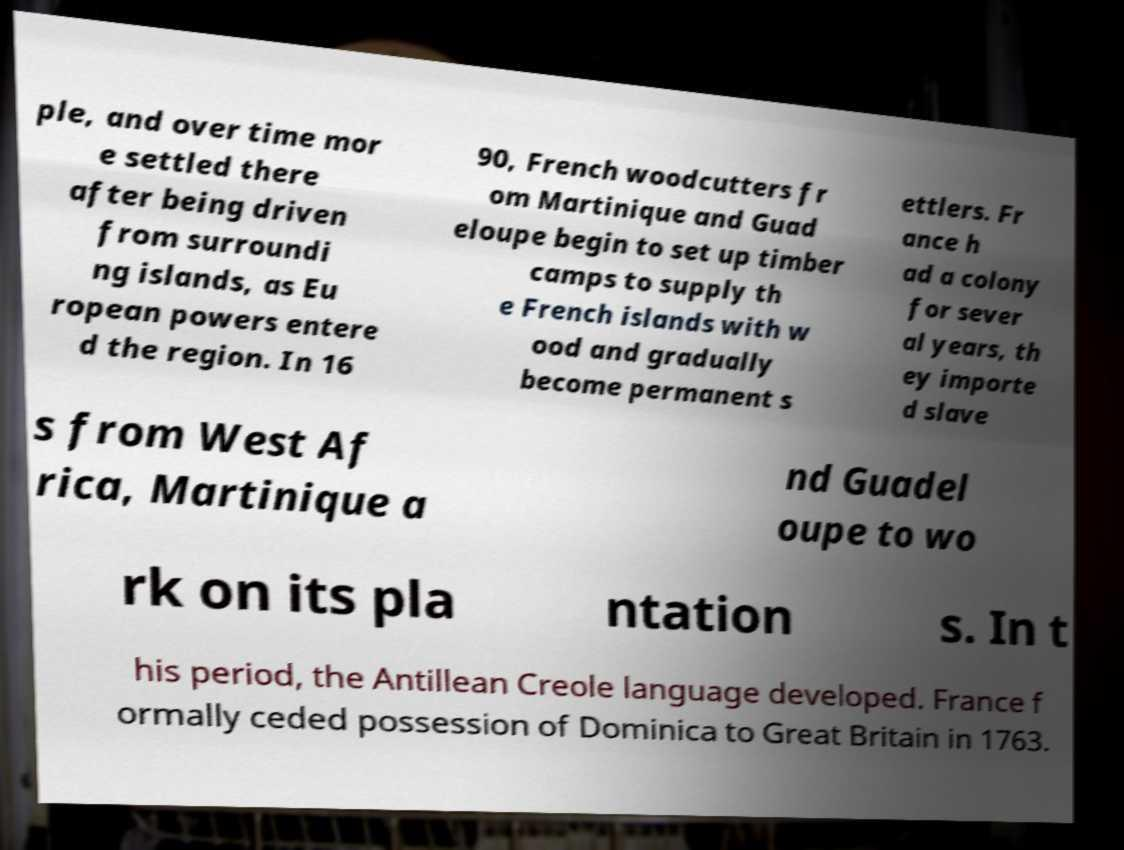For documentation purposes, I need the text within this image transcribed. Could you provide that? ple, and over time mor e settled there after being driven from surroundi ng islands, as Eu ropean powers entere d the region. In 16 90, French woodcutters fr om Martinique and Guad eloupe begin to set up timber camps to supply th e French islands with w ood and gradually become permanent s ettlers. Fr ance h ad a colony for sever al years, th ey importe d slave s from West Af rica, Martinique a nd Guadel oupe to wo rk on its pla ntation s. In t his period, the Antillean Creole language developed. France f ormally ceded possession of Dominica to Great Britain in 1763. 